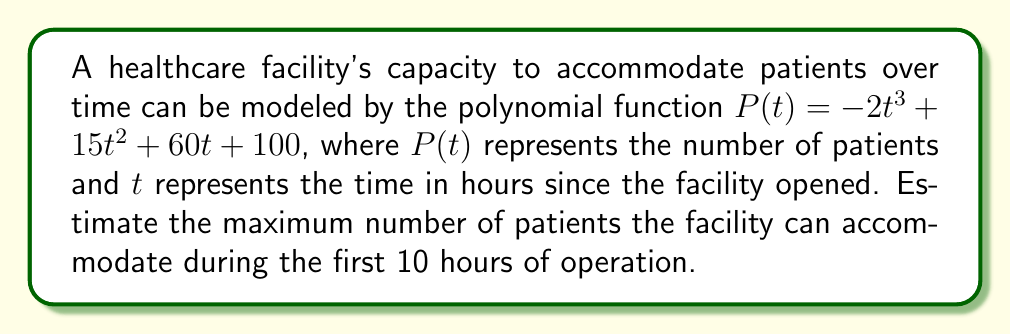Teach me how to tackle this problem. To find the maximum number of patients the facility can accommodate during the first 10 hours, we need to follow these steps:

1) The function $P(t) = -2t^3 + 15t^2 + 60t + 100$ is a cubic polynomial.

2) To find the maximum value, we need to find the critical points by taking the derivative and setting it equal to zero:

   $P'(t) = -6t^2 + 30t + 60$

3) Set $P'(t) = 0$:
   $-6t^2 + 30t + 60 = 0$

4) Solve this quadratic equation:
   $t = \frac{-30 \pm \sqrt{30^2 - 4(-6)(60)}}{2(-6)}$
   $t = \frac{-30 \pm \sqrt{900 + 1440}}{-12}$
   $t = \frac{-30 \pm \sqrt{2340}}{-12}$
   $t \approx 5.95$ or $t \approx 1.68$

5) The critical point within our domain (0 ≤ t ≤ 10) that gives the maximum is $t \approx 5.95$.

6) Evaluate $P(5.95)$:
   $P(5.95) = -2(5.95)^3 + 15(5.95)^2 + 60(5.95) + 100$
   $\approx -421.36 + 531.66 + 357 + 100$
   $\approx 567.3$

Therefore, the maximum number of patients the facility can accommodate during the first 10 hours is approximately 567.
Answer: 567 patients 